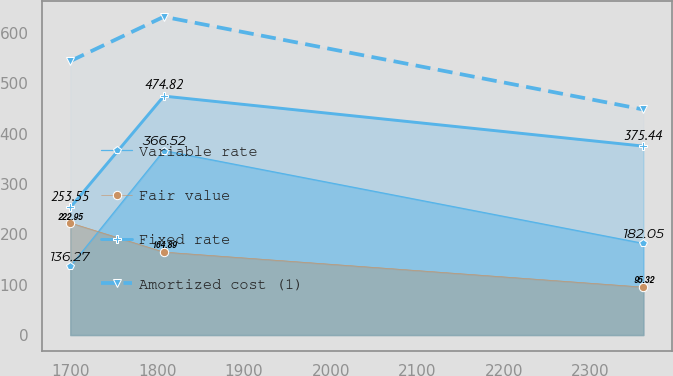Convert chart to OTSL. <chart><loc_0><loc_0><loc_500><loc_500><line_chart><ecel><fcel>Variable rate<fcel>Fair value<fcel>Fixed rate<fcel>Amortized cost (1)<nl><fcel>1699.16<fcel>136.27<fcel>222.95<fcel>253.55<fcel>544.39<nl><fcel>1807.23<fcel>366.52<fcel>164.89<fcel>474.82<fcel>632.53<nl><fcel>2361.35<fcel>182.05<fcel>95.32<fcel>375.44<fcel>448.21<nl></chart> 